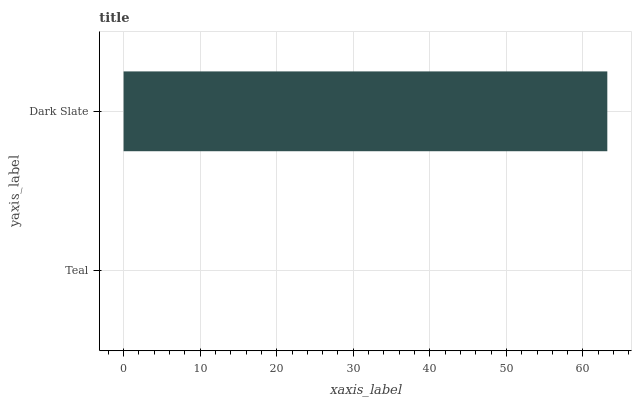Is Teal the minimum?
Answer yes or no. Yes. Is Dark Slate the maximum?
Answer yes or no. Yes. Is Dark Slate the minimum?
Answer yes or no. No. Is Dark Slate greater than Teal?
Answer yes or no. Yes. Is Teal less than Dark Slate?
Answer yes or no. Yes. Is Teal greater than Dark Slate?
Answer yes or no. No. Is Dark Slate less than Teal?
Answer yes or no. No. Is Dark Slate the high median?
Answer yes or no. Yes. Is Teal the low median?
Answer yes or no. Yes. Is Teal the high median?
Answer yes or no. No. Is Dark Slate the low median?
Answer yes or no. No. 